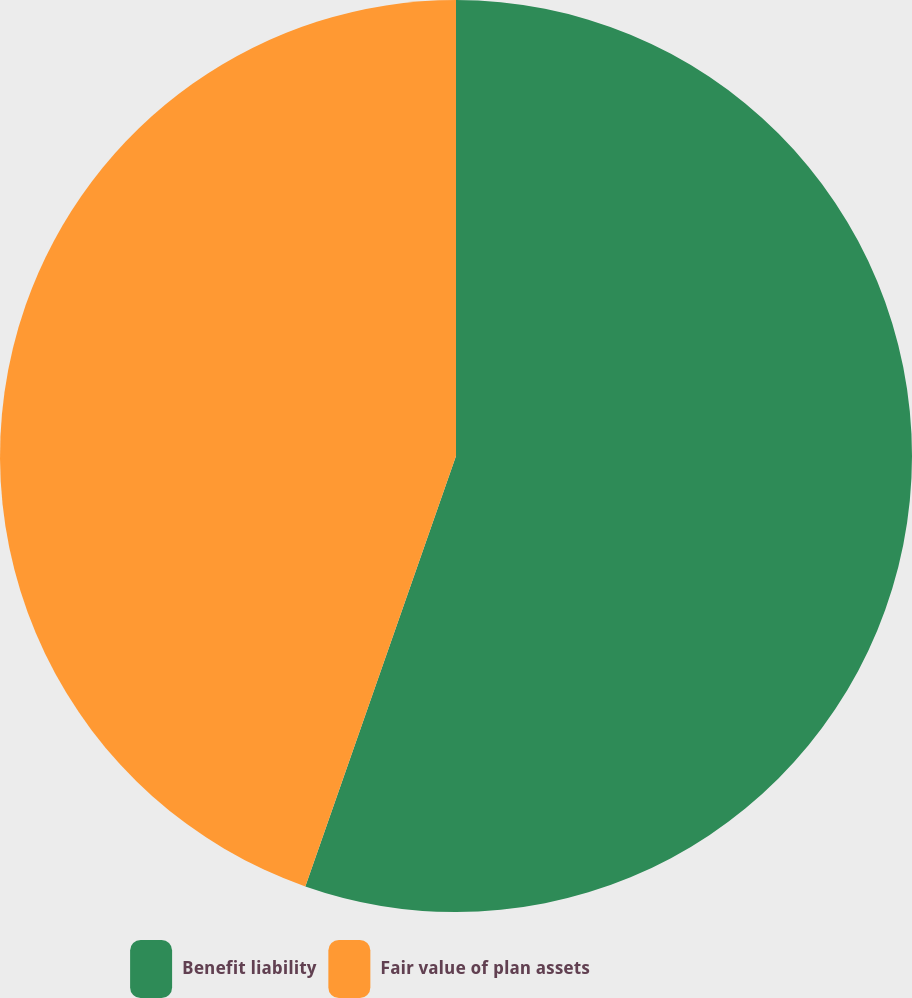Convert chart. <chart><loc_0><loc_0><loc_500><loc_500><pie_chart><fcel>Benefit liability<fcel>Fair value of plan assets<nl><fcel>55.36%<fcel>44.64%<nl></chart> 